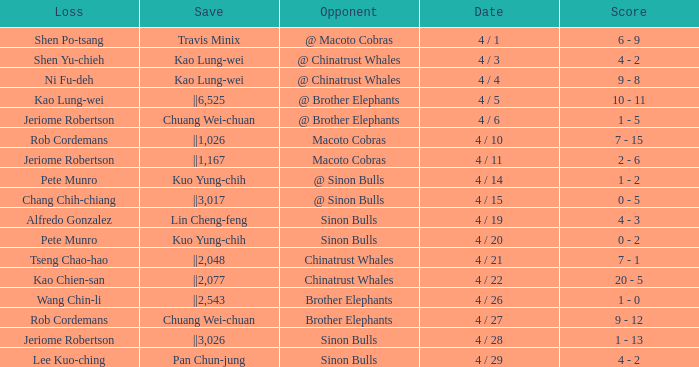Who earned the save in the game against the Sinon Bulls when Jeriome Robertson took the loss? ||3,026. 